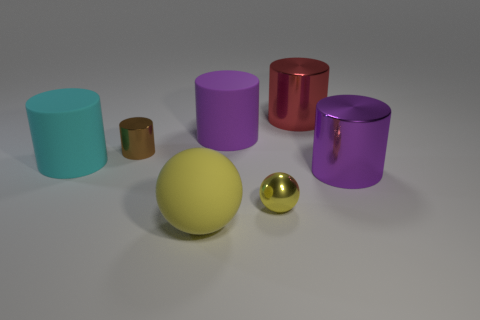What number of other tiny balls are the same color as the small sphere?
Your response must be concise. 0. Is the shape of the large purple thing that is to the right of the big red thing the same as  the large purple matte thing?
Ensure brevity in your answer.  Yes. There is a purple object behind the matte object to the left of the object that is in front of the small yellow shiny sphere; what shape is it?
Your response must be concise. Cylinder. How big is the yellow metallic object?
Provide a short and direct response. Small. There is a small object that is the same material as the tiny ball; what is its color?
Your response must be concise. Brown. What number of big yellow spheres have the same material as the cyan thing?
Make the answer very short. 1. Do the tiny sphere and the small metal thing that is left of the yellow metallic ball have the same color?
Your answer should be very brief. No. There is a small metallic thing that is left of the matte cylinder to the right of the rubber ball; what is its color?
Make the answer very short. Brown. There is another metallic object that is the same size as the red metal object; what color is it?
Provide a short and direct response. Purple. Are there any big red objects that have the same shape as the big cyan rubber thing?
Your response must be concise. Yes. 